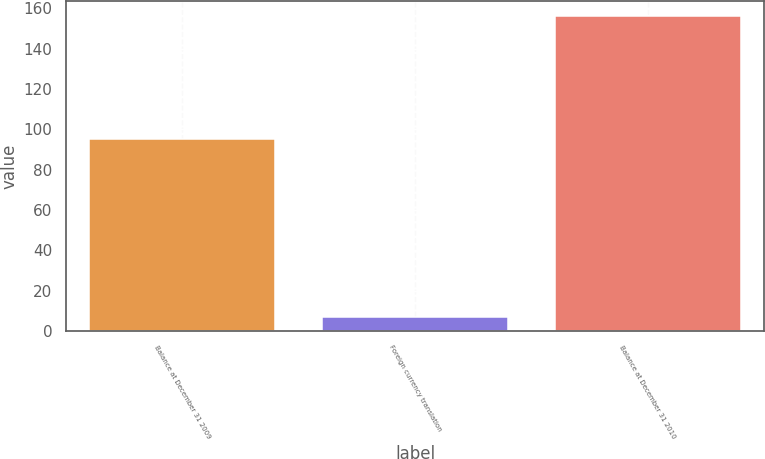Convert chart. <chart><loc_0><loc_0><loc_500><loc_500><bar_chart><fcel>Balance at December 31 2009<fcel>Foreign currency translation<fcel>Balance at December 31 2010<nl><fcel>95<fcel>7<fcel>156<nl></chart> 